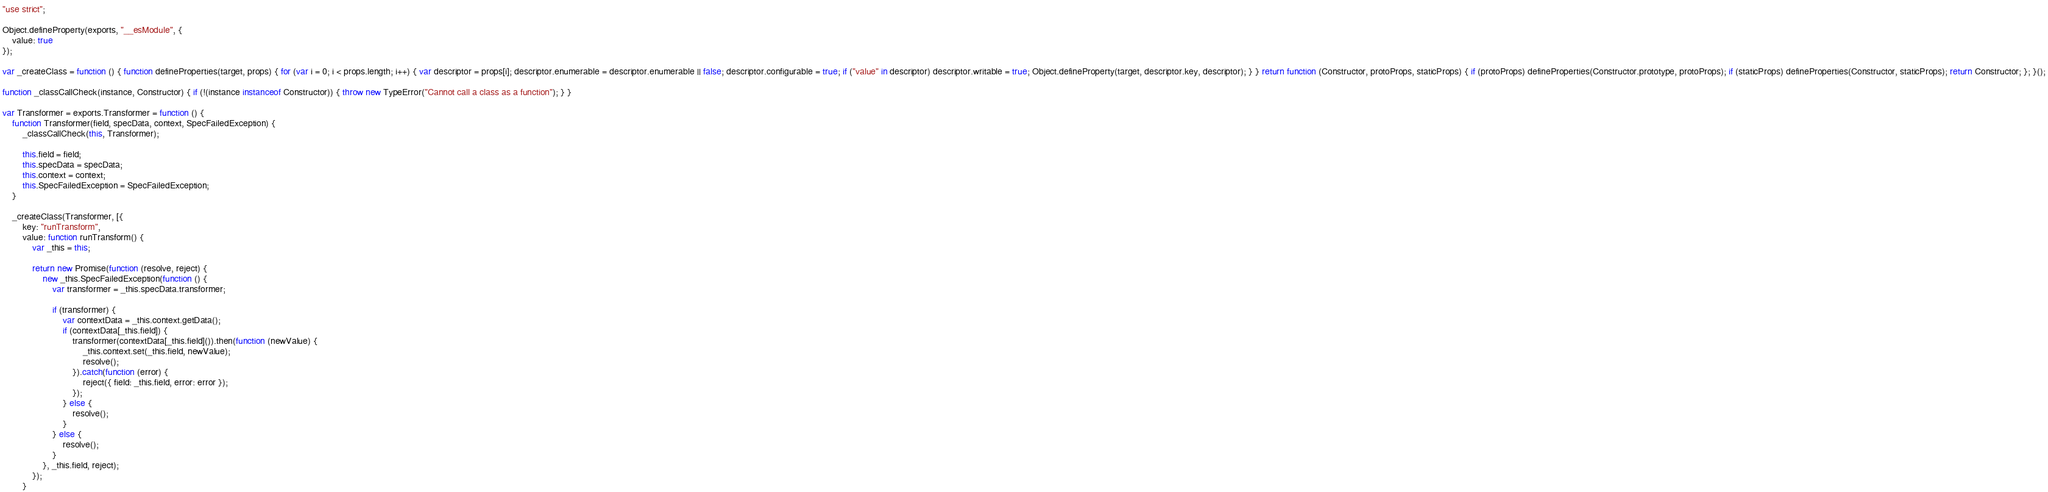<code> <loc_0><loc_0><loc_500><loc_500><_JavaScript_>"use strict";

Object.defineProperty(exports, "__esModule", {
    value: true
});

var _createClass = function () { function defineProperties(target, props) { for (var i = 0; i < props.length; i++) { var descriptor = props[i]; descriptor.enumerable = descriptor.enumerable || false; descriptor.configurable = true; if ("value" in descriptor) descriptor.writable = true; Object.defineProperty(target, descriptor.key, descriptor); } } return function (Constructor, protoProps, staticProps) { if (protoProps) defineProperties(Constructor.prototype, protoProps); if (staticProps) defineProperties(Constructor, staticProps); return Constructor; }; }();

function _classCallCheck(instance, Constructor) { if (!(instance instanceof Constructor)) { throw new TypeError("Cannot call a class as a function"); } }

var Transformer = exports.Transformer = function () {
    function Transformer(field, specData, context, SpecFailedException) {
        _classCallCheck(this, Transformer);

        this.field = field;
        this.specData = specData;
        this.context = context;
        this.SpecFailedException = SpecFailedException;
    }

    _createClass(Transformer, [{
        key: "runTransform",
        value: function runTransform() {
            var _this = this;

            return new Promise(function (resolve, reject) {
                new _this.SpecFailedException(function () {
                    var transformer = _this.specData.transformer;

                    if (transformer) {
                        var contextData = _this.context.getData();
                        if (contextData[_this.field]) {
                            transformer(contextData[_this.field]()).then(function (newValue) {
                                _this.context.set(_this.field, newValue);
                                resolve();
                            }).catch(function (error) {
                                reject({ field: _this.field, error: error });
                            });
                        } else {
                            resolve();
                        }
                    } else {
                        resolve();
                    }
                }, _this.field, reject);
            });
        }</code> 